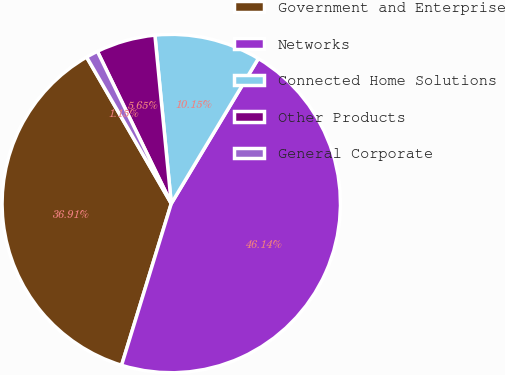<chart> <loc_0><loc_0><loc_500><loc_500><pie_chart><fcel>Government and Enterprise<fcel>Networks<fcel>Connected Home Solutions<fcel>Other Products<fcel>General Corporate<nl><fcel>36.91%<fcel>46.14%<fcel>10.15%<fcel>5.65%<fcel>1.15%<nl></chart> 